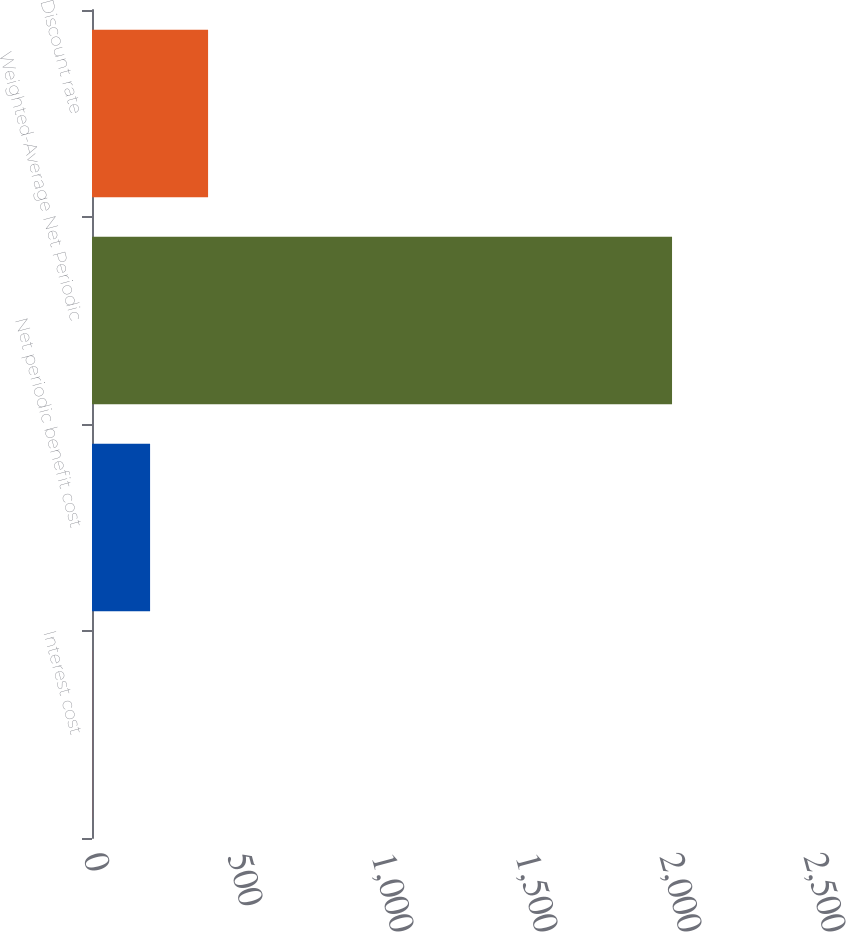<chart> <loc_0><loc_0><loc_500><loc_500><bar_chart><fcel>Interest cost<fcel>Net periodic benefit cost<fcel>Weighted-Average Net Periodic<fcel>Discount rate<nl><fcel>0.3<fcel>201.67<fcel>2014<fcel>403.04<nl></chart> 